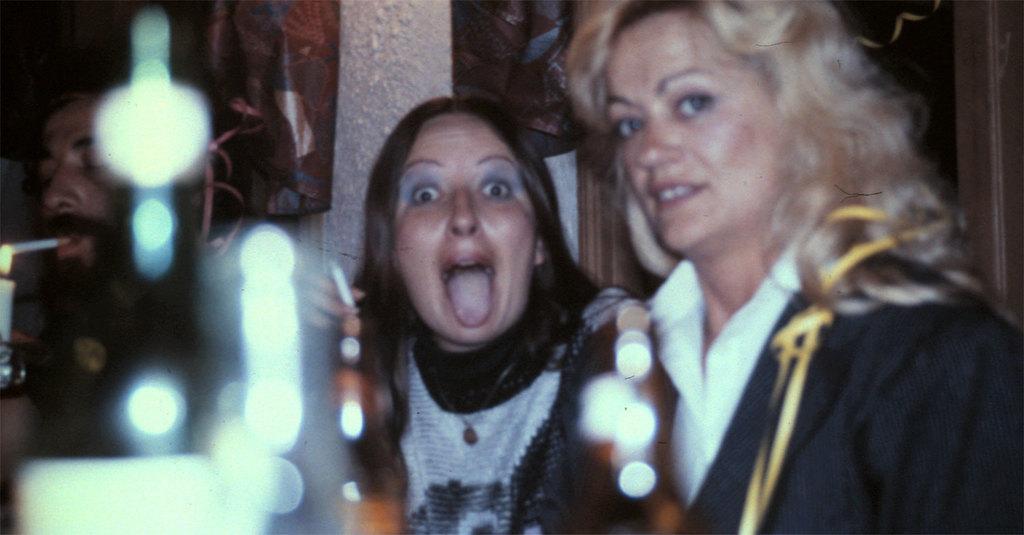How would you summarize this image in a sentence or two? In this picture we can see two women and a man in the front, on the left side there is a candle, this man is smoking a cigar, there is a dark background. 